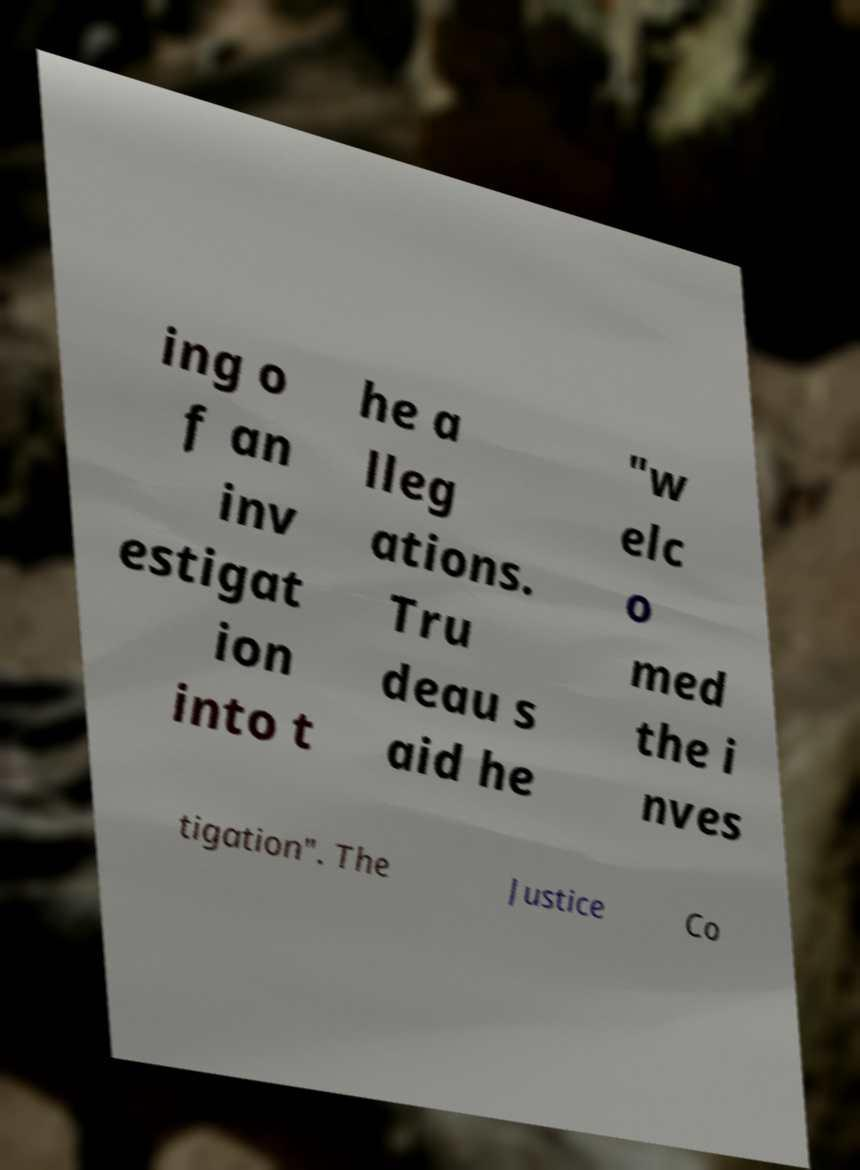Please identify and transcribe the text found in this image. ing o f an inv estigat ion into t he a lleg ations. Tru deau s aid he "w elc o med the i nves tigation". The Justice Co 